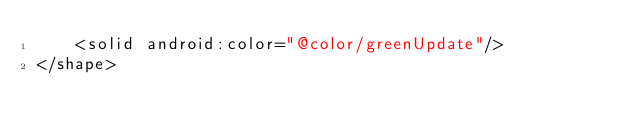Convert code to text. <code><loc_0><loc_0><loc_500><loc_500><_XML_>    <solid android:color="@color/greenUpdate"/>
</shape>
</code> 